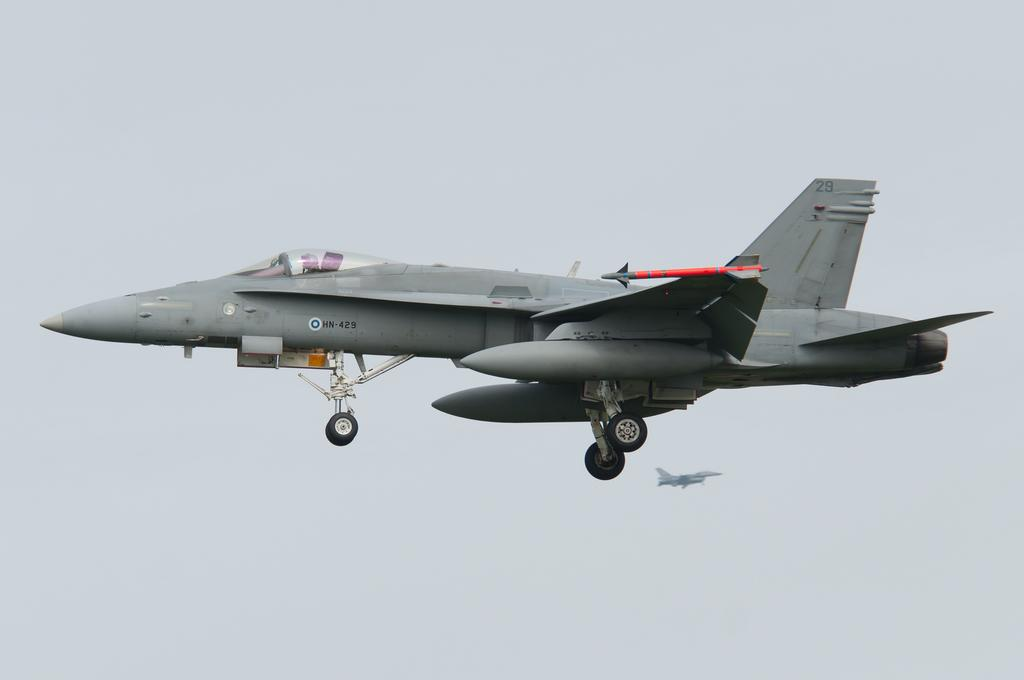What is the main subject of the image? The main subject of the image is airplanes. What are the airplanes doing in the image? The airplanes are flying in the sky. How many lizards can be seen swimming in the water in the image? There are no lizards or water present in the image; it features airplanes flying in the sky. 